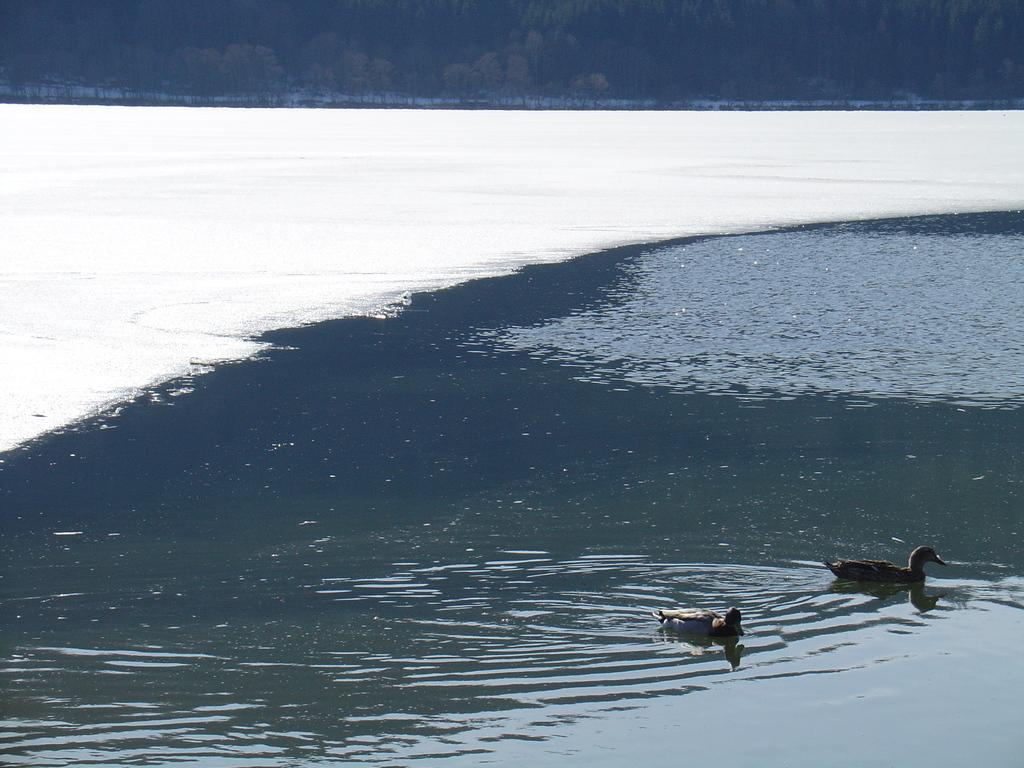What animals can be seen in the image? There are ducks in the water in the image. What can be seen in the background of the image? There are trees visible in the background of the image. What type of railway can be seen in the image? There is no railway present in the image; it features ducks in the water and trees in the background. What is the ducks using to hammer the dirt in the image? There is no hammer or dirt present in the image, and the ducks are not performing any such activity. 